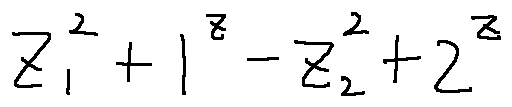<formula> <loc_0><loc_0><loc_500><loc_500>z _ { 1 } ^ { 2 } + 1 ^ { z } - z _ { 2 } ^ { 2 } + 2 ^ { z }</formula> 